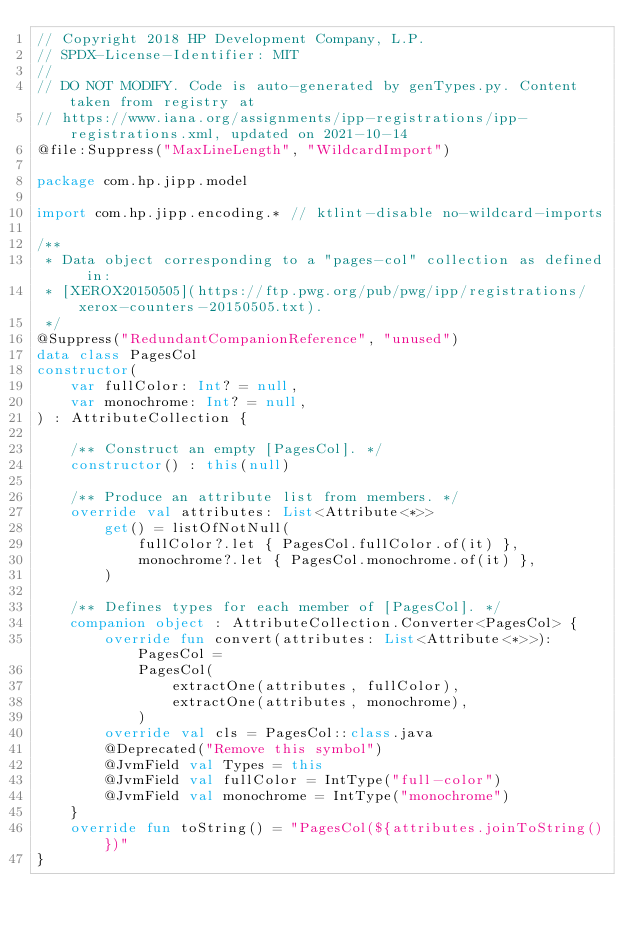<code> <loc_0><loc_0><loc_500><loc_500><_Kotlin_>// Copyright 2018 HP Development Company, L.P.
// SPDX-License-Identifier: MIT
//
// DO NOT MODIFY. Code is auto-generated by genTypes.py. Content taken from registry at
// https://www.iana.org/assignments/ipp-registrations/ipp-registrations.xml, updated on 2021-10-14
@file:Suppress("MaxLineLength", "WildcardImport")

package com.hp.jipp.model

import com.hp.jipp.encoding.* // ktlint-disable no-wildcard-imports

/**
 * Data object corresponding to a "pages-col" collection as defined in:
 * [XEROX20150505](https://ftp.pwg.org/pub/pwg/ipp/registrations/xerox-counters-20150505.txt).
 */
@Suppress("RedundantCompanionReference", "unused")
data class PagesCol
constructor(
    var fullColor: Int? = null,
    var monochrome: Int? = null,
) : AttributeCollection {

    /** Construct an empty [PagesCol]. */
    constructor() : this(null)

    /** Produce an attribute list from members. */
    override val attributes: List<Attribute<*>>
        get() = listOfNotNull(
            fullColor?.let { PagesCol.fullColor.of(it) },
            monochrome?.let { PagesCol.monochrome.of(it) },
        )

    /** Defines types for each member of [PagesCol]. */
    companion object : AttributeCollection.Converter<PagesCol> {
        override fun convert(attributes: List<Attribute<*>>): PagesCol =
            PagesCol(
                extractOne(attributes, fullColor),
                extractOne(attributes, monochrome),
            )
        override val cls = PagesCol::class.java
        @Deprecated("Remove this symbol")
        @JvmField val Types = this
        @JvmField val fullColor = IntType("full-color")
        @JvmField val monochrome = IntType("monochrome")
    }
    override fun toString() = "PagesCol(${attributes.joinToString()})"
}
</code> 